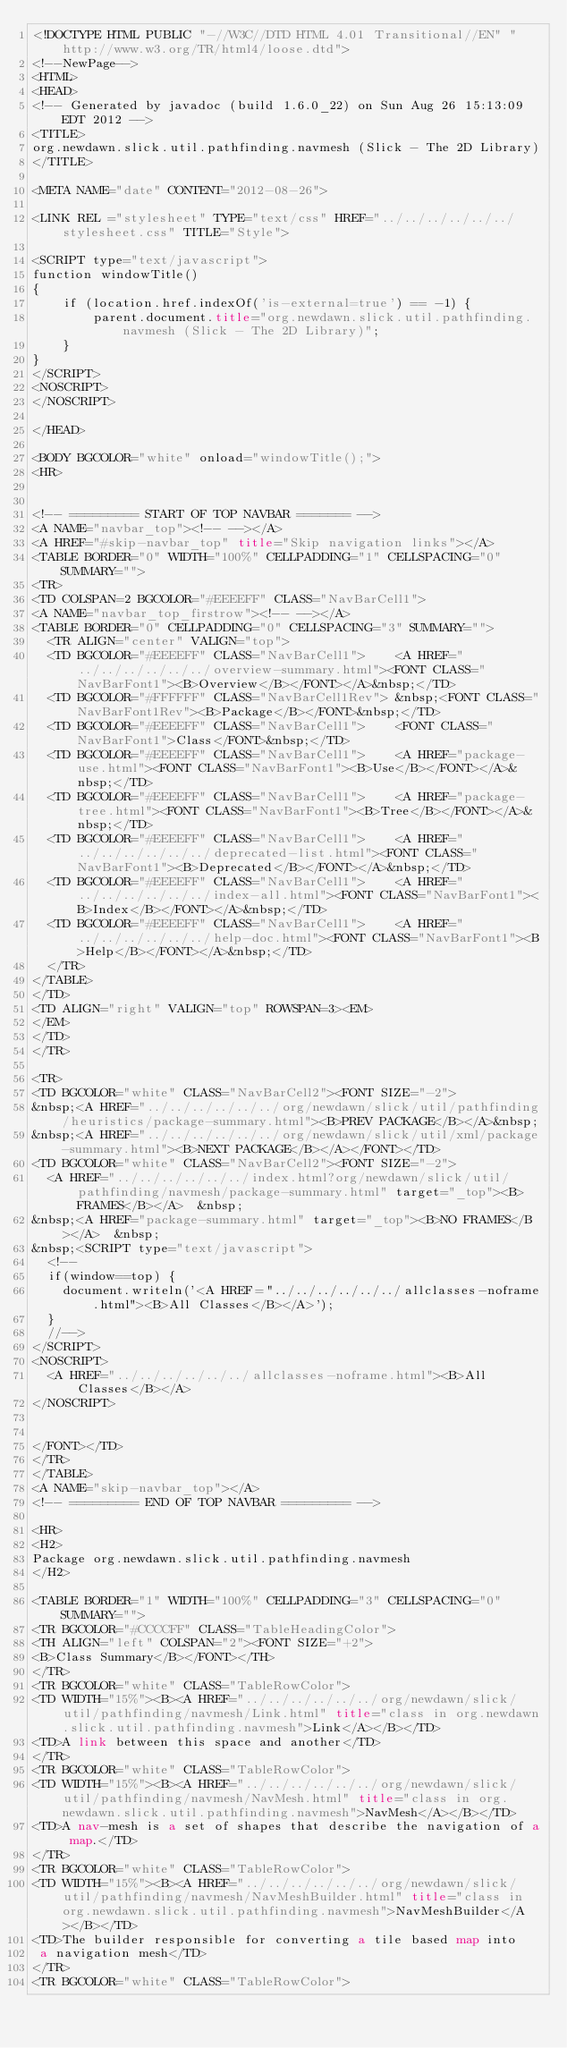Convert code to text. <code><loc_0><loc_0><loc_500><loc_500><_HTML_><!DOCTYPE HTML PUBLIC "-//W3C//DTD HTML 4.01 Transitional//EN" "http://www.w3.org/TR/html4/loose.dtd">
<!--NewPage-->
<HTML>
<HEAD>
<!-- Generated by javadoc (build 1.6.0_22) on Sun Aug 26 15:13:09 EDT 2012 -->
<TITLE>
org.newdawn.slick.util.pathfinding.navmesh (Slick - The 2D Library)
</TITLE>

<META NAME="date" CONTENT="2012-08-26">

<LINK REL ="stylesheet" TYPE="text/css" HREF="../../../../../../stylesheet.css" TITLE="Style">

<SCRIPT type="text/javascript">
function windowTitle()
{
    if (location.href.indexOf('is-external=true') == -1) {
        parent.document.title="org.newdawn.slick.util.pathfinding.navmesh (Slick - The 2D Library)";
    }
}
</SCRIPT>
<NOSCRIPT>
</NOSCRIPT>

</HEAD>

<BODY BGCOLOR="white" onload="windowTitle();">
<HR>


<!-- ========= START OF TOP NAVBAR ======= -->
<A NAME="navbar_top"><!-- --></A>
<A HREF="#skip-navbar_top" title="Skip navigation links"></A>
<TABLE BORDER="0" WIDTH="100%" CELLPADDING="1" CELLSPACING="0" SUMMARY="">
<TR>
<TD COLSPAN=2 BGCOLOR="#EEEEFF" CLASS="NavBarCell1">
<A NAME="navbar_top_firstrow"><!-- --></A>
<TABLE BORDER="0" CELLPADDING="0" CELLSPACING="3" SUMMARY="">
  <TR ALIGN="center" VALIGN="top">
  <TD BGCOLOR="#EEEEFF" CLASS="NavBarCell1">    <A HREF="../../../../../../overview-summary.html"><FONT CLASS="NavBarFont1"><B>Overview</B></FONT></A>&nbsp;</TD>
  <TD BGCOLOR="#FFFFFF" CLASS="NavBarCell1Rev"> &nbsp;<FONT CLASS="NavBarFont1Rev"><B>Package</B></FONT>&nbsp;</TD>
  <TD BGCOLOR="#EEEEFF" CLASS="NavBarCell1">    <FONT CLASS="NavBarFont1">Class</FONT>&nbsp;</TD>
  <TD BGCOLOR="#EEEEFF" CLASS="NavBarCell1">    <A HREF="package-use.html"><FONT CLASS="NavBarFont1"><B>Use</B></FONT></A>&nbsp;</TD>
  <TD BGCOLOR="#EEEEFF" CLASS="NavBarCell1">    <A HREF="package-tree.html"><FONT CLASS="NavBarFont1"><B>Tree</B></FONT></A>&nbsp;</TD>
  <TD BGCOLOR="#EEEEFF" CLASS="NavBarCell1">    <A HREF="../../../../../../deprecated-list.html"><FONT CLASS="NavBarFont1"><B>Deprecated</B></FONT></A>&nbsp;</TD>
  <TD BGCOLOR="#EEEEFF" CLASS="NavBarCell1">    <A HREF="../../../../../../index-all.html"><FONT CLASS="NavBarFont1"><B>Index</B></FONT></A>&nbsp;</TD>
  <TD BGCOLOR="#EEEEFF" CLASS="NavBarCell1">    <A HREF="../../../../../../help-doc.html"><FONT CLASS="NavBarFont1"><B>Help</B></FONT></A>&nbsp;</TD>
  </TR>
</TABLE>
</TD>
<TD ALIGN="right" VALIGN="top" ROWSPAN=3><EM>
</EM>
</TD>
</TR>

<TR>
<TD BGCOLOR="white" CLASS="NavBarCell2"><FONT SIZE="-2">
&nbsp;<A HREF="../../../../../../org/newdawn/slick/util/pathfinding/heuristics/package-summary.html"><B>PREV PACKAGE</B></A>&nbsp;
&nbsp;<A HREF="../../../../../../org/newdawn/slick/util/xml/package-summary.html"><B>NEXT PACKAGE</B></A></FONT></TD>
<TD BGCOLOR="white" CLASS="NavBarCell2"><FONT SIZE="-2">
  <A HREF="../../../../../../index.html?org/newdawn/slick/util/pathfinding/navmesh/package-summary.html" target="_top"><B>FRAMES</B></A>  &nbsp;
&nbsp;<A HREF="package-summary.html" target="_top"><B>NO FRAMES</B></A>  &nbsp;
&nbsp;<SCRIPT type="text/javascript">
  <!--
  if(window==top) {
    document.writeln('<A HREF="../../../../../../allclasses-noframe.html"><B>All Classes</B></A>');
  }
  //-->
</SCRIPT>
<NOSCRIPT>
  <A HREF="../../../../../../allclasses-noframe.html"><B>All Classes</B></A>
</NOSCRIPT>


</FONT></TD>
</TR>
</TABLE>
<A NAME="skip-navbar_top"></A>
<!-- ========= END OF TOP NAVBAR ========= -->

<HR>
<H2>
Package org.newdawn.slick.util.pathfinding.navmesh
</H2>

<TABLE BORDER="1" WIDTH="100%" CELLPADDING="3" CELLSPACING="0" SUMMARY="">
<TR BGCOLOR="#CCCCFF" CLASS="TableHeadingColor">
<TH ALIGN="left" COLSPAN="2"><FONT SIZE="+2">
<B>Class Summary</B></FONT></TH>
</TR>
<TR BGCOLOR="white" CLASS="TableRowColor">
<TD WIDTH="15%"><B><A HREF="../../../../../../org/newdawn/slick/util/pathfinding/navmesh/Link.html" title="class in org.newdawn.slick.util.pathfinding.navmesh">Link</A></B></TD>
<TD>A link between this space and another</TD>
</TR>
<TR BGCOLOR="white" CLASS="TableRowColor">
<TD WIDTH="15%"><B><A HREF="../../../../../../org/newdawn/slick/util/pathfinding/navmesh/NavMesh.html" title="class in org.newdawn.slick.util.pathfinding.navmesh">NavMesh</A></B></TD>
<TD>A nav-mesh is a set of shapes that describe the navigation of a map.</TD>
</TR>
<TR BGCOLOR="white" CLASS="TableRowColor">
<TD WIDTH="15%"><B><A HREF="../../../../../../org/newdawn/slick/util/pathfinding/navmesh/NavMeshBuilder.html" title="class in org.newdawn.slick.util.pathfinding.navmesh">NavMeshBuilder</A></B></TD>
<TD>The builder responsible for converting a tile based map into
 a navigation mesh</TD>
</TR>
<TR BGCOLOR="white" CLASS="TableRowColor"></code> 